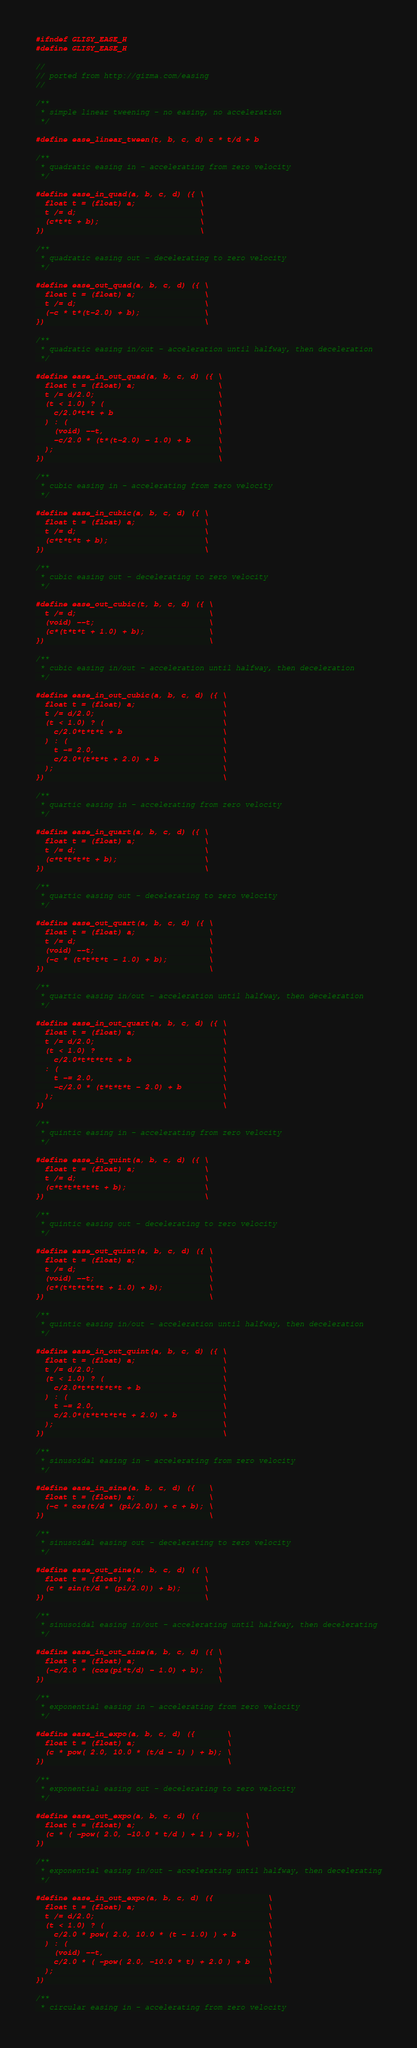<code> <loc_0><loc_0><loc_500><loc_500><_C_>#ifndef GLISY_EASE_H
#define GLISY_EASE_H

//
// ported from http://gizma.com/easing
//

/**
 * simple linear tweening - no easing, no acceleration
 */

#define ease_linear_tween(t, b, c, d) c * t/d + b

/**
 * quadratic easing in - accelerating from zero velocity
 */

#define ease_in_quad(a, b, c, d) ({ \
  float t = (float) a;              \
  t /= d;                           \
  (c*t*t + b);                      \
})                                  \

/**
 * quadratic easing out - decelerating to zero velocity
 */

#define ease_out_quad(a, b, c, d) ({ \
  float t = (float) a;               \
  t /= d;                            \
  (-c * t*(t-2.0) + b);              \
})                                   \

/**
 * quadratic easing in/out - acceleration until halfway, then deceleration
 */

#define ease_in_out_quad(a, b, c, d) ({ \
  float t = (float) a;                  \
  t /= d/2.0;                           \
  (t < 1.0) ? (                         \
    c/2.0*t*t + b                       \
  ) : (                                 \
    (void) --t,                         \
    -c/2.0 * (t*(t-2.0) - 1.0) + b      \
  );                                    \
})                                      \

/**
 * cubic easing in - accelerating from zero velocity
 */

#define ease_in_cubic(a, b, c, d) ({ \
  float t = (float) a;               \
  t /= d;                            \
  (c*t*t*t + b);                     \
})                                   \

/**
 * cubic easing out - decelerating to zero velocity
 */

#define ease_out_cubic(t, b, c, d) ({ \
  t /= d;                             \
  (void) --t;                         \
  (c*(t*t*t + 1.0) + b);              \
})                                    \

/**
 * cubic easing in/out - acceleration until halfway, then deceleration
 */

#define ease_in_out_cubic(a, b, c, d) ({ \
  float t = (float) a;                   \
  t /= d/2.0;                            \
  (t < 1.0) ? (                          \
    c/2.0*t*t*t + b                      \
  ) : (                                  \
    t -= 2.0,                            \
    c/2.0*(t*t*t + 2.0) + b              \
  );                                     \
})                                       \

/**
 * quartic easing in - accelerating from zero velocity
 */

#define ease_in_quart(a, b, c, d) ({ \
  float t = (float) a;               \
  t /= d;                            \
  (c*t*t*t*t + b);                   \
})                                   \

/**
 * quartic easing out - decelerating to zero velocity
 */

#define ease_out_quart(a, b, c, d) ({ \
  float t = (float) a;                \
  t /= d;                             \
  (void) --t;                         \
  (-c * (t*t*t*t - 1.0) + b);         \
})                                    \

/**
 * quartic easing in/out - acceleration until halfway, then deceleration
 */

#define ease_in_out_quart(a, b, c, d) ({ \
  float t = (float) a;                   \
  t /= d/2.0;                            \
  (t < 1.0) ?                            \
    c/2.0*t*t*t*t + b                    \
  : (                                    \
    t -= 2.0,                            \
    -c/2.0 * (t*t*t*t - 2.0) + b         \
  );                                     \
})                                       \

/**
 * quintic easing in - accelerating from zero velocity
 */

#define ease_in_quint(a, b, c, d) ({ \
  float t = (float) a;               \
  t /= d;                            \
  (c*t*t*t*t*t + b);                 \
})                                   \

/**
 * quintic easing out - decelerating to zero velocity
 */

#define ease_out_quint(a, b, c, d) ({ \
  float t = (float) a;                \
  t /= d;                             \
  (void) --t;                         \
  (c*(t*t*t*t*t + 1.0) + b);          \
})                                    \

/**
 * quintic easing in/out - acceleration until halfway, then deceleration
 */

#define ease_in_out_quint(a, b, c, d) ({ \
  float t = (float) a;                   \
  t /= d/2.0;                            \
  (t < 1.0) ? (                          \
    c/2.0*t*t*t*t*t + b                  \
  ) : (                                  \
    t -= 2.0,                            \
    c/2.0*(t*t*t*t*t + 2.0) + b          \
  );                                     \
})                                       \

/**
 * sinusoidal easing in - accelerating from zero velocity
 */

#define ease_in_sine(a, b, c, d) ({   \
  float t = (float) a;                \
  (-c * cos(t/d * (pi/2.0)) + c + b); \
})                                    \

/**
 * sinusoidal easing out - decelerating to zero velocity
 */

#define ease_out_sine(a, b, c, d) ({ \
  float t = (float) a;               \
  (c * sin(t/d * (pi/2.0)) + b);     \
})                                   \

/**
 * sinusoidal easing in/out - accelerating until halfway, then decelerating
 */

#define ease_in_out_sine(a, b, c, d) ({ \
  float t = (float) a;                  \
  (-c/2.0 * (cos(pi*t/d) - 1.0) + b);   \
})                                      \

/**
 * exponential easing in - accelerating from zero velocity
 */

#define ease_in_expo(a, b, c, d) ({       \
  float t = (float) a;                    \
  (c * pow( 2.0, 10.0 * (t/d - 1) ) + b); \
})                                        \

/**
 * exponential easing out - decelerating to zero velocity
 */

#define ease_out_expo(a, b, c, d) ({          \
  float t = (float) a;                        \
  (c * ( -pow( 2.0, -10.0 * t/d ) + 1 ) + b); \
})                                            \

/**
 * exponential easing in/out - accelerating until halfway, then decelerating
 */

#define ease_in_out_expo(a, b, c, d) ({            \
  float t = (float) a;                             \
  t /= d/2.0;                                      \
  (t < 1.0) ? (                                    \
    c/2.0 * pow( 2.0, 10.0 * (t - 1.0) ) + b       \
  ) : (                                            \
    (void) --t,                                    \
    c/2.0 * ( -pow( 2.0, -10.0 * t) + 2.0 ) + b    \
  );                                               \
})                                                 \

/**
 * circular easing in - accelerating from zero velocity</code> 